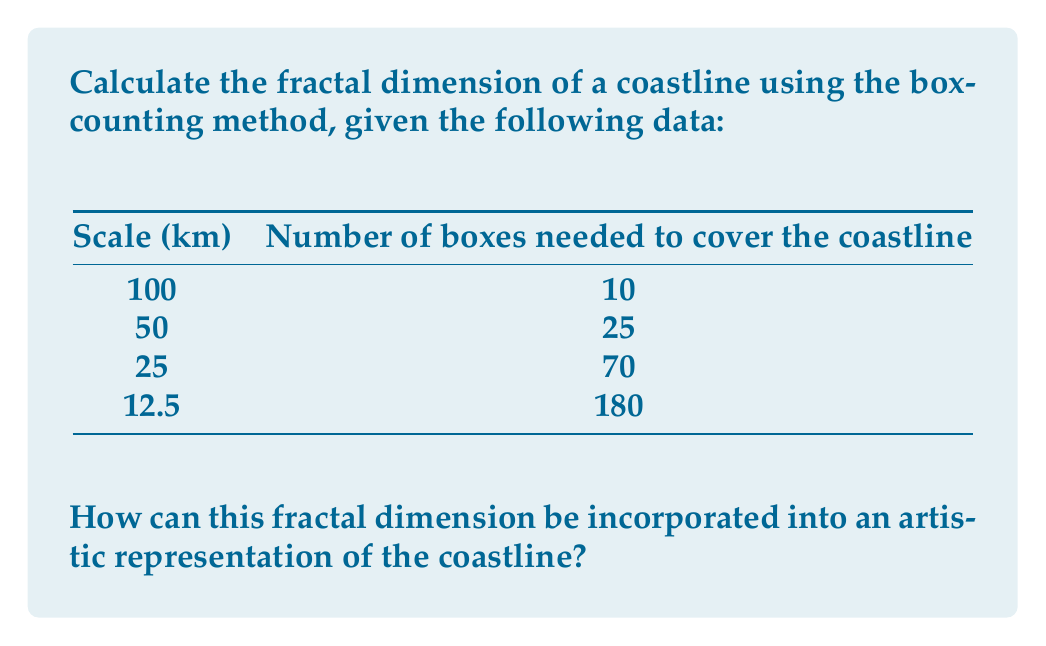Can you answer this question? To calculate the fractal dimension using the box-counting method, we follow these steps:

1. The fractal dimension $D$ is given by the formula:

   $$D = -\lim_{\epsilon \to 0} \frac{\log N(\epsilon)}{\log \epsilon}$$

   where $N(\epsilon)$ is the number of boxes of size $\epsilon$ needed to cover the object.

2. In practice, we estimate $D$ by plotting $\log N(\epsilon)$ against $\log(1/\epsilon)$ and finding the slope of the best-fit line.

3. Let's prepare our data:

   Scale ($\epsilon$) | $1/\epsilon$ | $N(\epsilon)$ | $\log(1/\epsilon)$ | $\log N(\epsilon)$
   100 km             | 0.01         | 10            | -2                 | 1
   50 km              | 0.02         | 25            | -1.699             | 1.398
   25 km              | 0.04         | 70            | -1.398             | 1.845
   12.5 km            | 0.08         | 180           | -1.097             | 2.255

4. Plot these points ($\log(1/\epsilon)$, $\log N(\epsilon)$) and fit a line.

5. The slope of this line is our estimate of $D$. We can calculate it using the formula:

   $$D \approx \frac{\Delta \log N(\epsilon)}{\Delta \log(1/\epsilon)}$$

6. Using the first and last points:

   $$D \approx \frac{2.255 - 1}{-1.097 - (-2)} = \frac{1.255}{0.903} \approx 1.39$$

This fractal dimension can be incorporated into artwork by:

1. Using iterative patterns that repeat at different scales, mimicking the coastline's complexity.
2. Creating a series of artworks at different scales, each revealing more detail.
3. Using the fractal dimension to determine the level of detail in different parts of the artwork, with more intricate patterns in areas representing the coastline.
Answer: The fractal dimension of the coastline is approximately 1.39. 